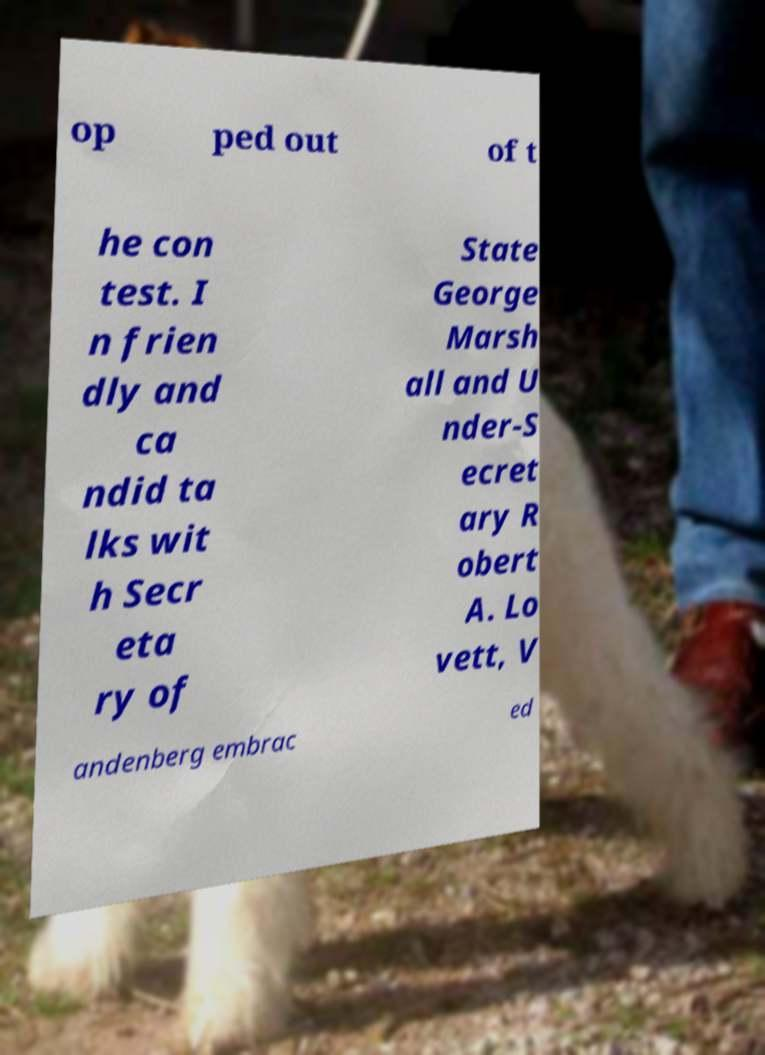For documentation purposes, I need the text within this image transcribed. Could you provide that? op ped out of t he con test. I n frien dly and ca ndid ta lks wit h Secr eta ry of State George Marsh all and U nder-S ecret ary R obert A. Lo vett, V andenberg embrac ed 